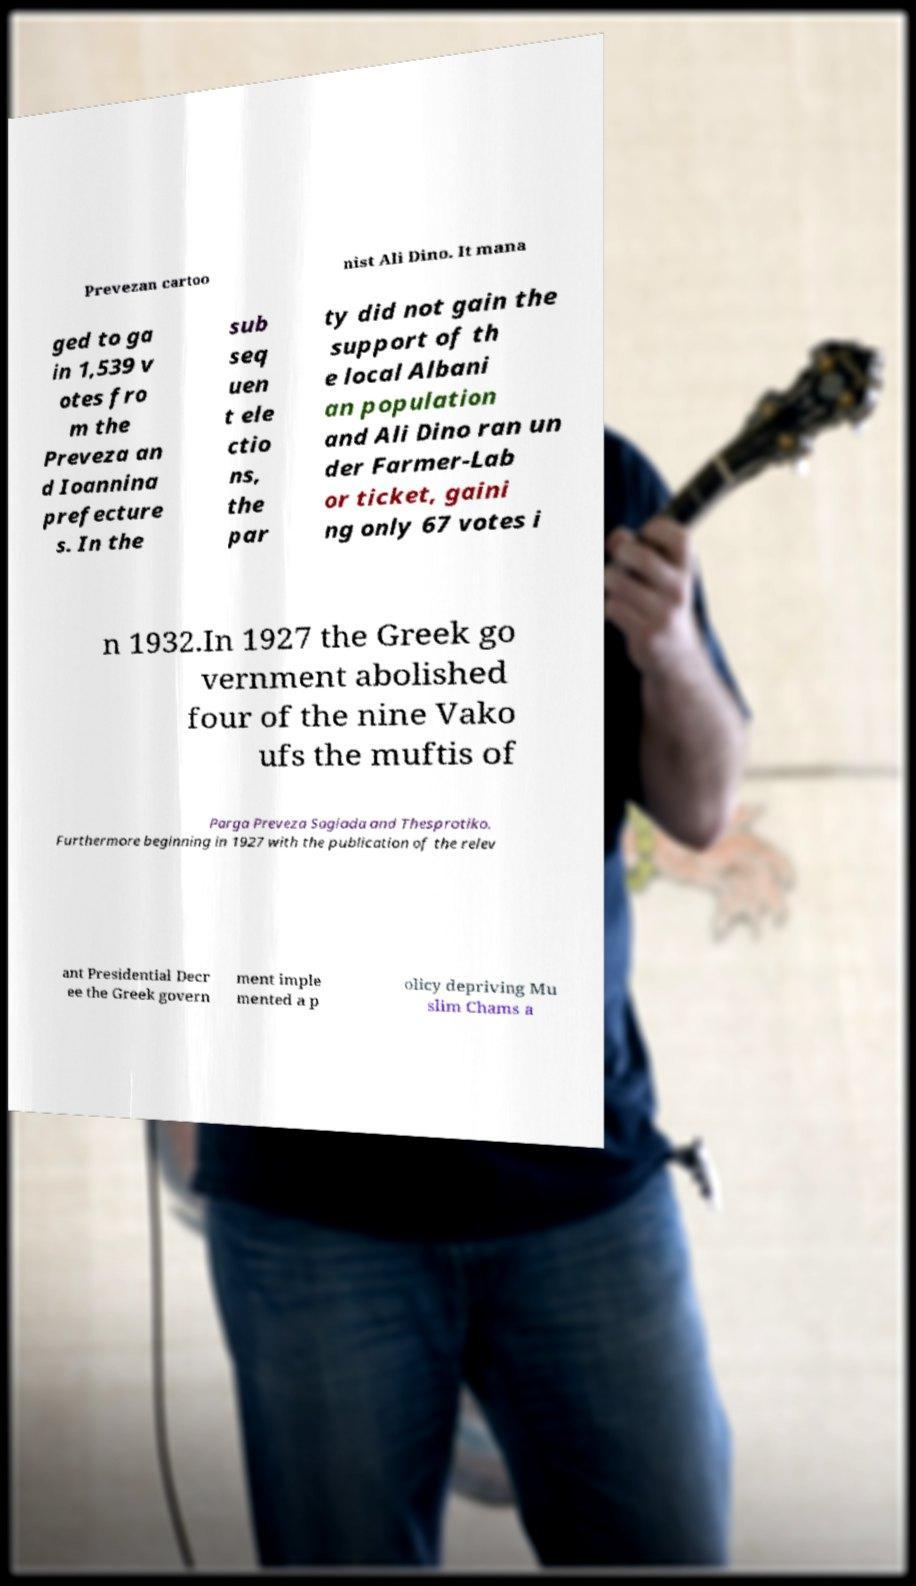Can you read and provide the text displayed in the image?This photo seems to have some interesting text. Can you extract and type it out for me? Prevezan cartoo nist Ali Dino. It mana ged to ga in 1,539 v otes fro m the Preveza an d Ioannina prefecture s. In the sub seq uen t ele ctio ns, the par ty did not gain the support of th e local Albani an population and Ali Dino ran un der Farmer-Lab or ticket, gaini ng only 67 votes i n 1932.In 1927 the Greek go vernment abolished four of the nine Vako ufs the muftis of Parga Preveza Sagiada and Thesprotiko. Furthermore beginning in 1927 with the publication of the relev ant Presidential Decr ee the Greek govern ment imple mented a p olicy depriving Mu slim Chams a 